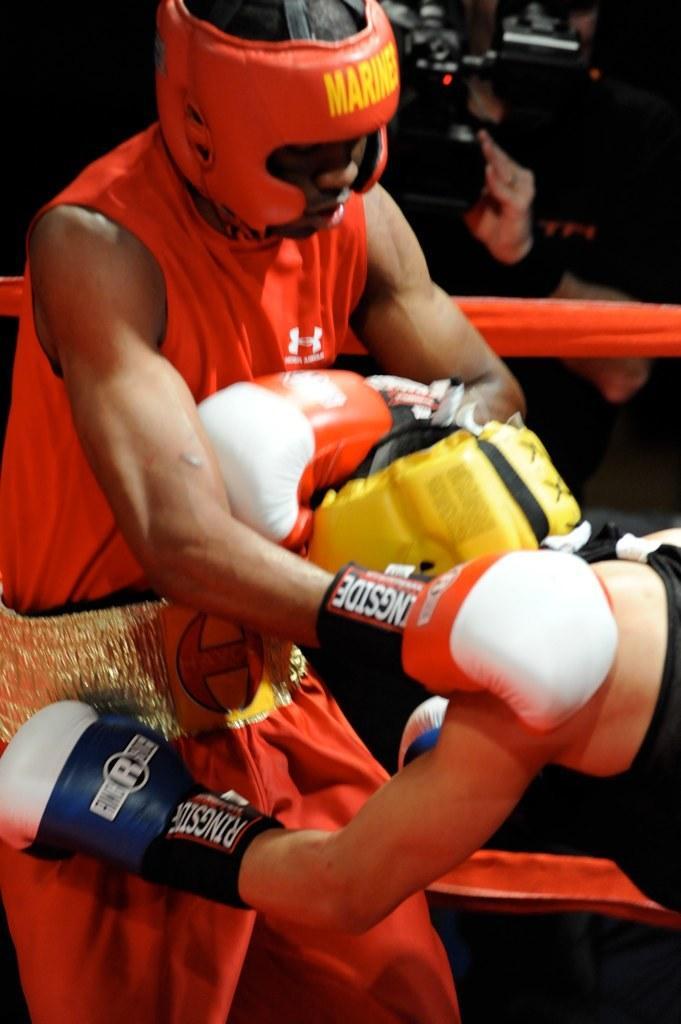In one or two sentences, can you explain what this image depicts? In this image we can see two persons are standing, they are boxing, at the back a man is standing, and holding the camera in the hands. 